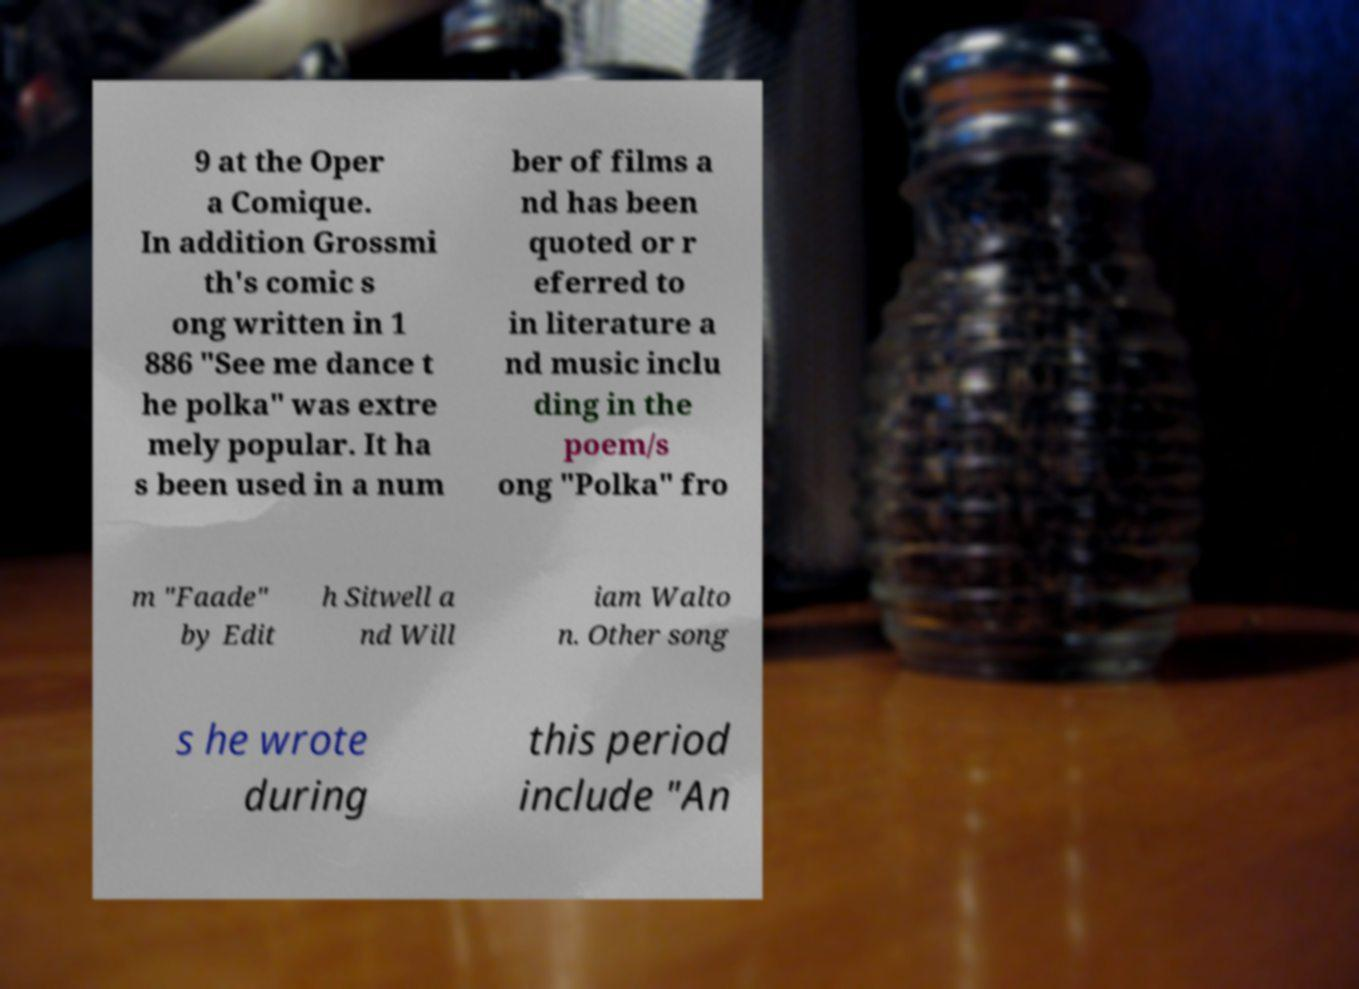Please identify and transcribe the text found in this image. 9 at the Oper a Comique. In addition Grossmi th's comic s ong written in 1 886 "See me dance t he polka" was extre mely popular. It ha s been used in a num ber of films a nd has been quoted or r eferred to in literature a nd music inclu ding in the poem/s ong "Polka" fro m "Faade" by Edit h Sitwell a nd Will iam Walto n. Other song s he wrote during this period include "An 